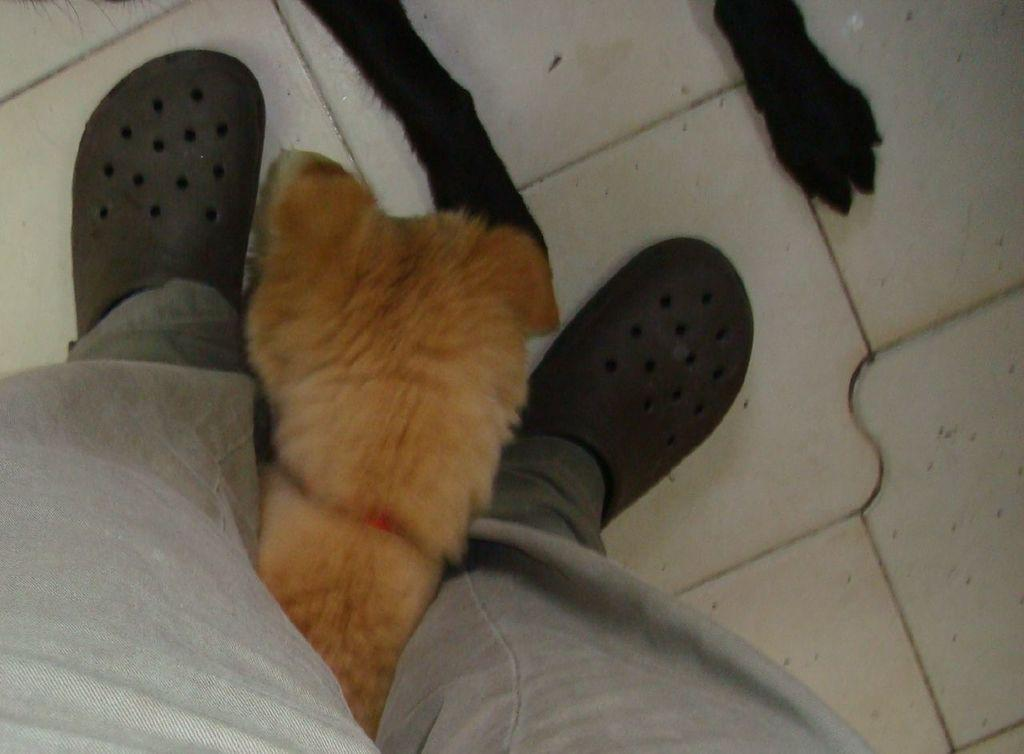What body parts of a man can be seen in the image? There are feet of a man in the image. What animals are present in the image? There are two legs of a dog and the head of another dog in the image. Where are all these elements located in the image? All these elements are on the floor. What type of business is being conducted in the image? There is no indication of any business activity in the image; it primarily features the body parts of a man and dogs on the floor. Can you see any grass in the image? There is no grass visible in the image. 